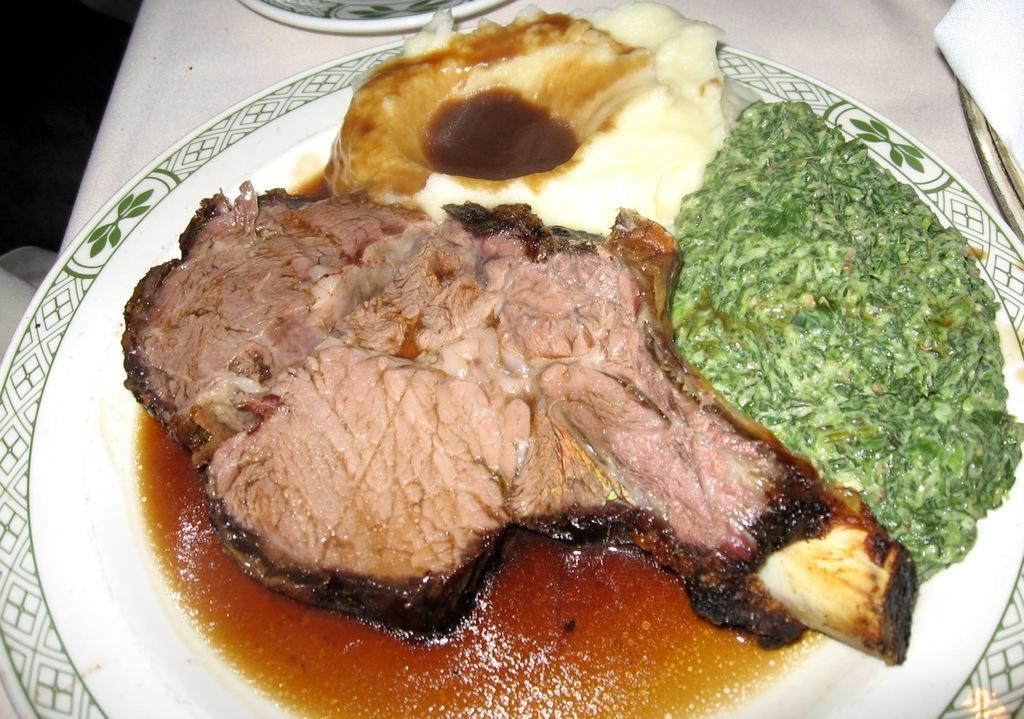Describe this image in one or two sentences. In this picture there is a plate in the center of the image, which contains food items and beef in it. 